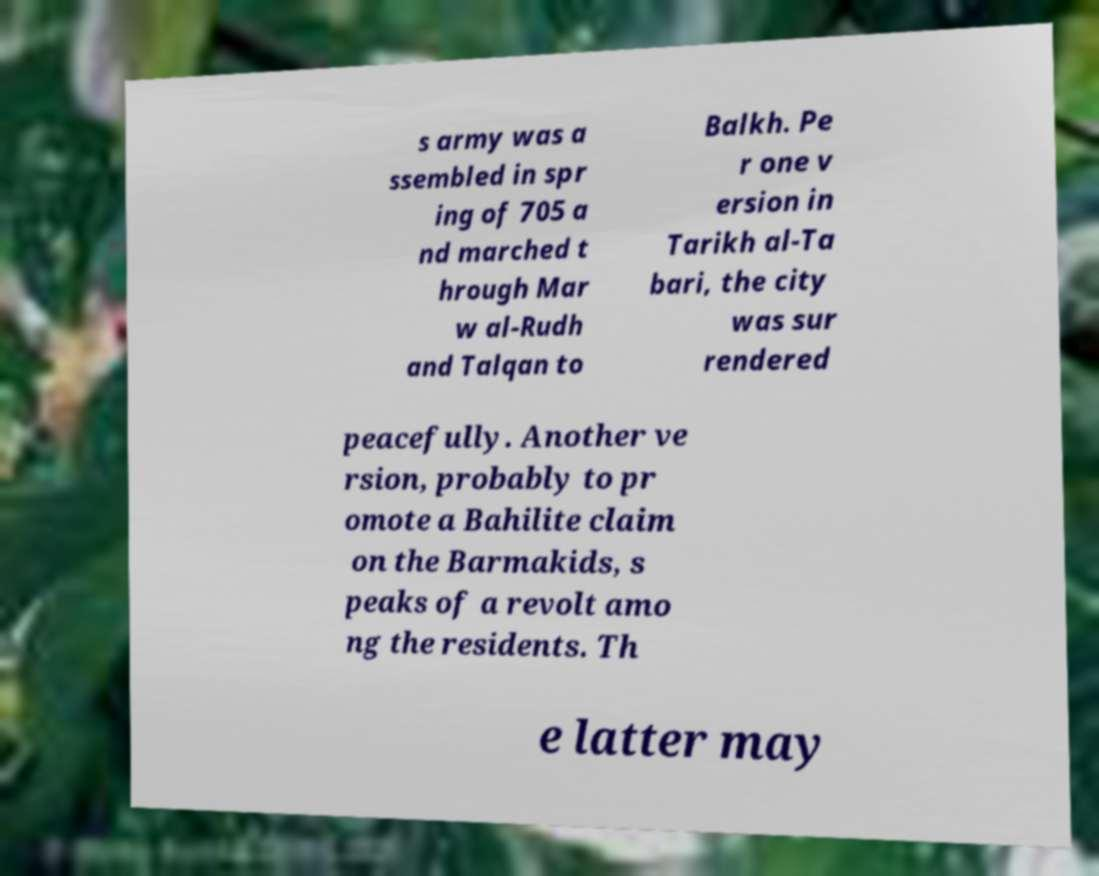Could you extract and type out the text from this image? s army was a ssembled in spr ing of 705 a nd marched t hrough Mar w al-Rudh and Talqan to Balkh. Pe r one v ersion in Tarikh al-Ta bari, the city was sur rendered peacefully. Another ve rsion, probably to pr omote a Bahilite claim on the Barmakids, s peaks of a revolt amo ng the residents. Th e latter may 